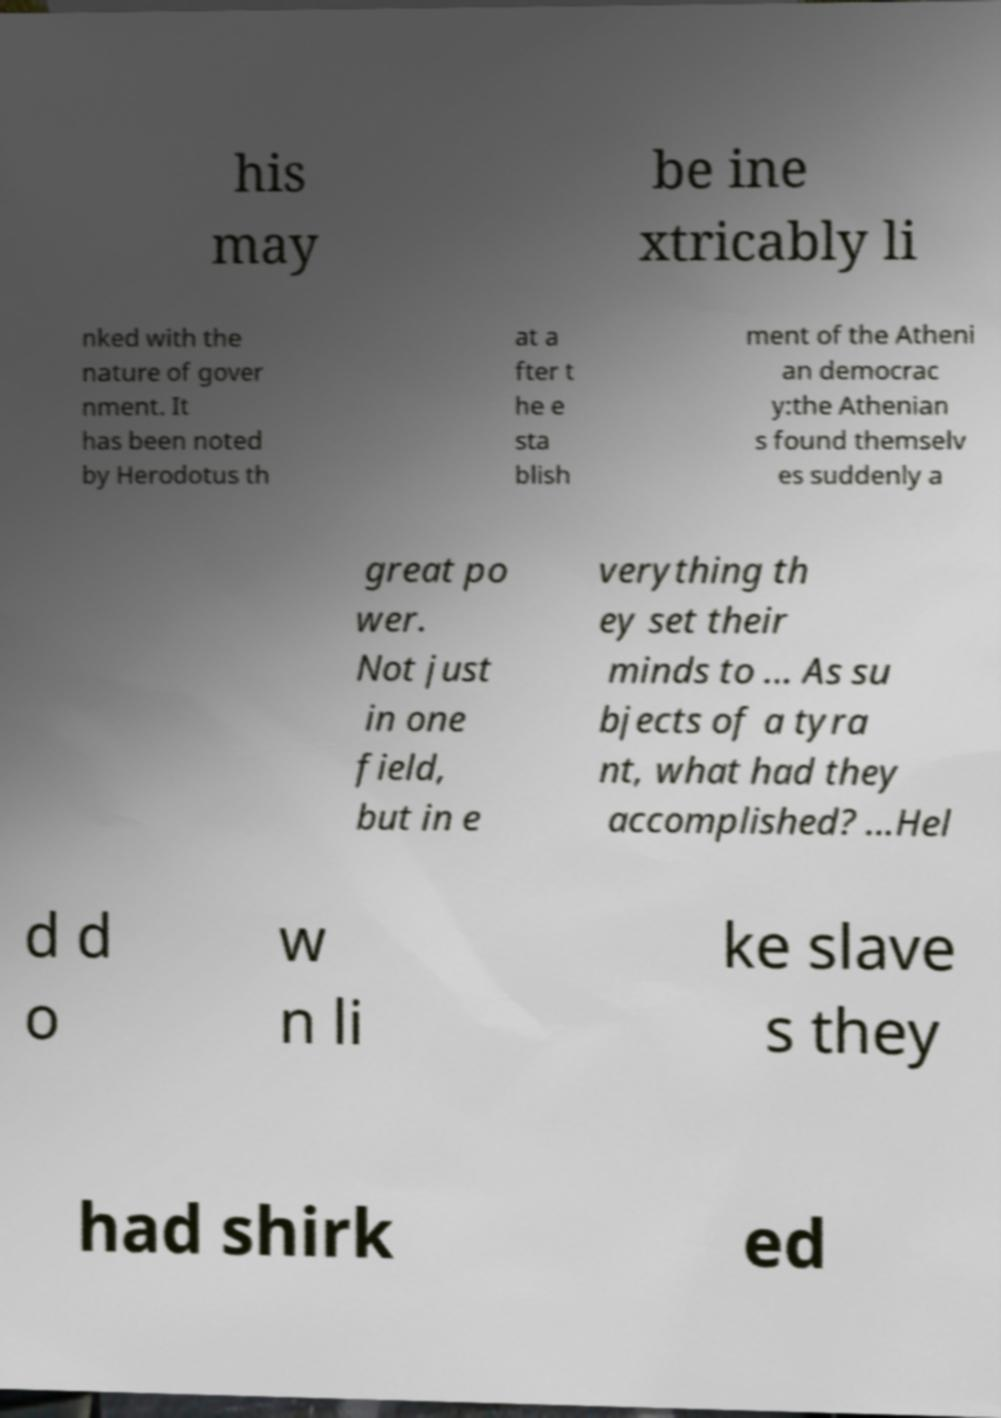There's text embedded in this image that I need extracted. Can you transcribe it verbatim? his may be ine xtricably li nked with the nature of gover nment. It has been noted by Herodotus th at a fter t he e sta blish ment of the Atheni an democrac y:the Athenian s found themselv es suddenly a great po wer. Not just in one field, but in e verything th ey set their minds to ... As su bjects of a tyra nt, what had they accomplished? ...Hel d d o w n li ke slave s they had shirk ed 